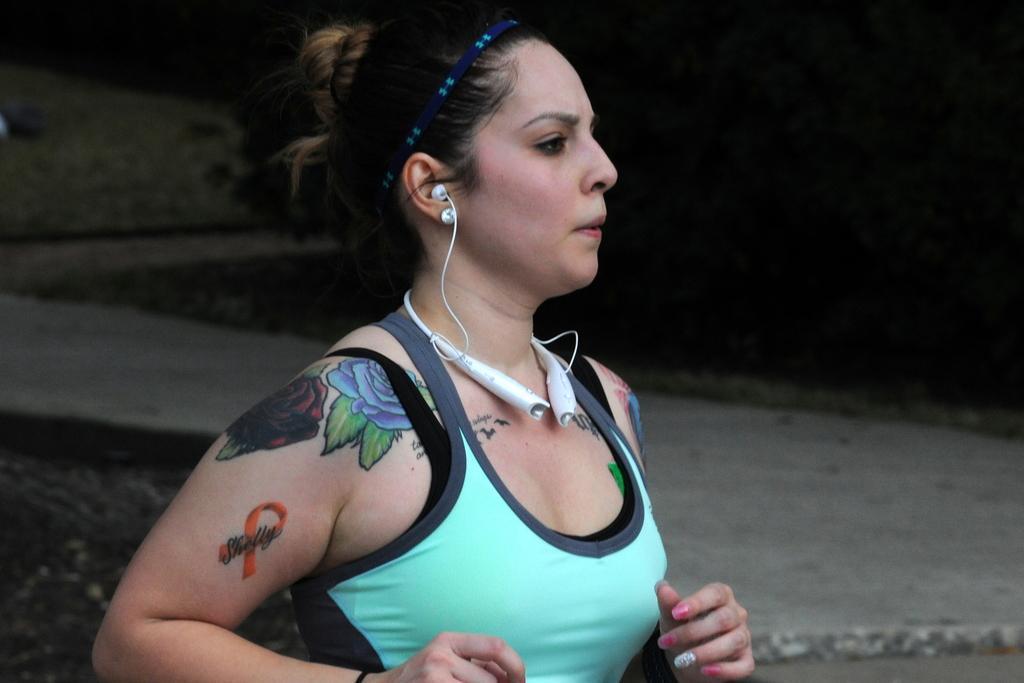In one or two sentences, can you explain what this image depicts? In this image I can see a girl running and wearing Bluetooth headset and the background is black. 